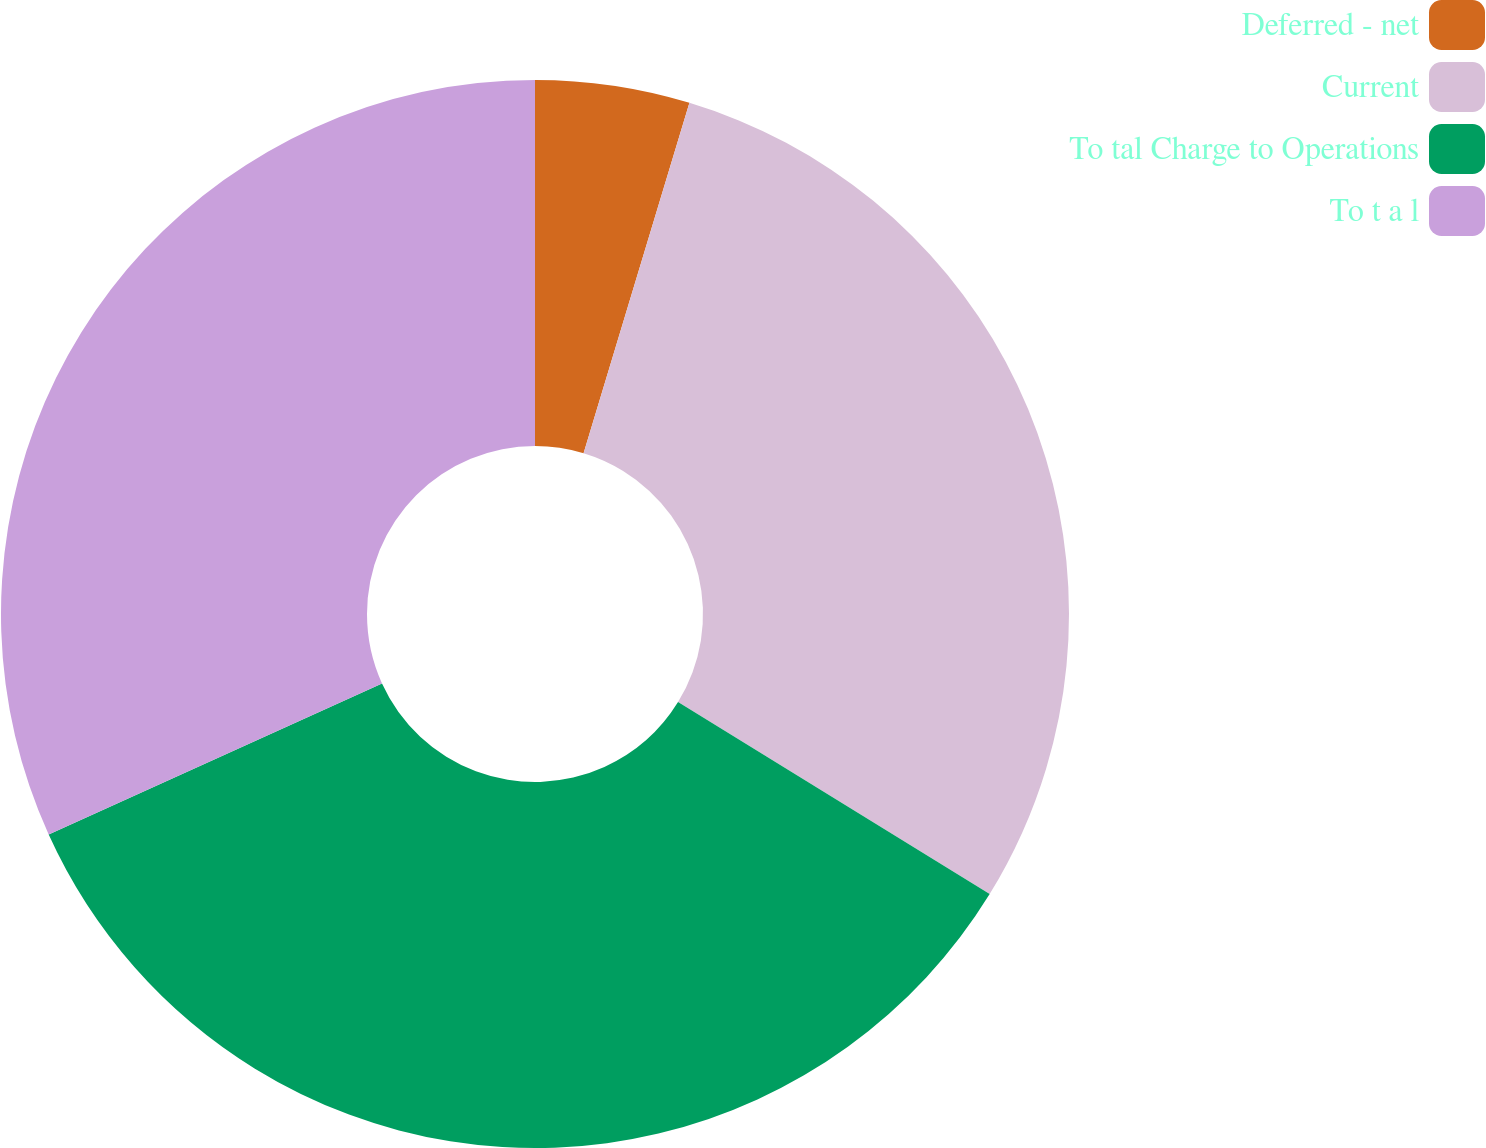<chart> <loc_0><loc_0><loc_500><loc_500><pie_chart><fcel>Deferred - net<fcel>Current<fcel>To tal Charge to Operations<fcel>To t a l<nl><fcel>4.67%<fcel>29.12%<fcel>34.44%<fcel>31.78%<nl></chart> 